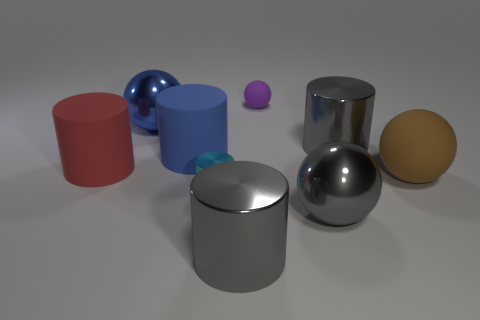Subtract all cyan cylinders. How many cylinders are left? 4 Subtract all tiny metallic cylinders. How many cylinders are left? 4 Subtract 1 spheres. How many spheres are left? 3 Subtract all purple cylinders. Subtract all blue spheres. How many cylinders are left? 5 Subtract all balls. How many objects are left? 5 Add 1 tiny cyan objects. How many tiny cyan objects are left? 2 Add 8 large matte balls. How many large matte balls exist? 9 Subtract 1 red cylinders. How many objects are left? 8 Subtract all large cyan metal things. Subtract all tiny matte spheres. How many objects are left? 8 